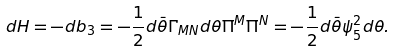Convert formula to latex. <formula><loc_0><loc_0><loc_500><loc_500>d H = - d b _ { 3 } = - \frac { 1 } { 2 } d \bar { \theta } \Gamma _ { M N } d \theta \Pi ^ { M } \Pi ^ { N } = - \frac { 1 } { 2 } d \bar { \theta } \psi _ { 5 } ^ { 2 } d \theta .</formula> 